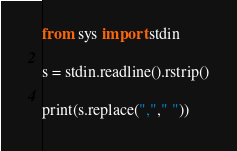Convert code to text. <code><loc_0><loc_0><loc_500><loc_500><_Python_>from sys import stdin

s = stdin.readline().rstrip()

print(s.replace(","," "))</code> 